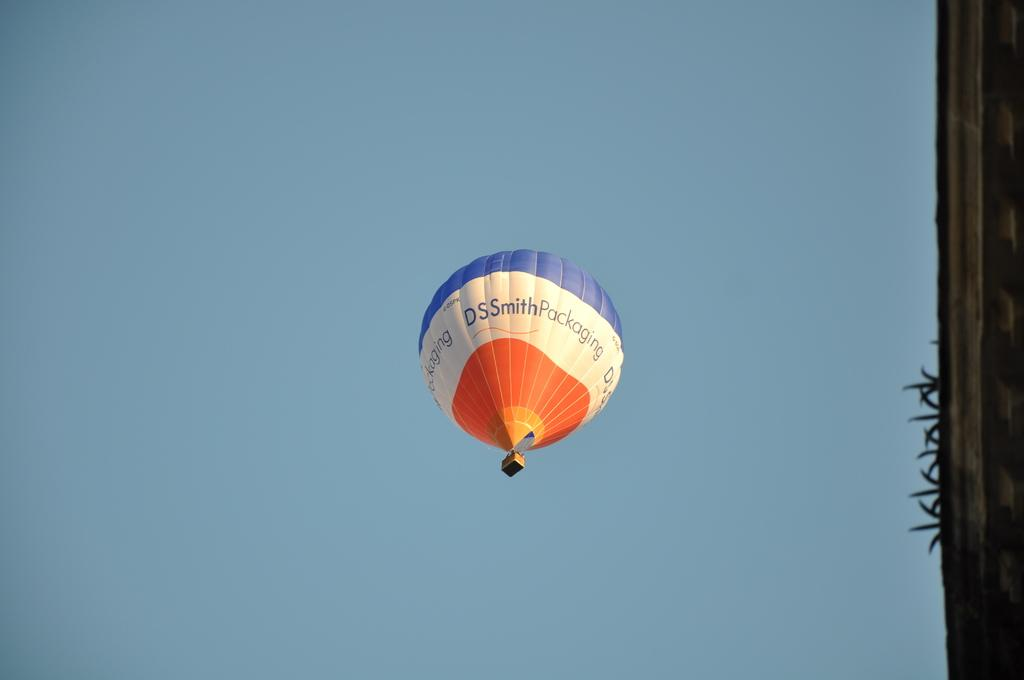Provide a one-sentence caption for the provided image. A hot air balloon in the air advertising DSsmith packaging. 